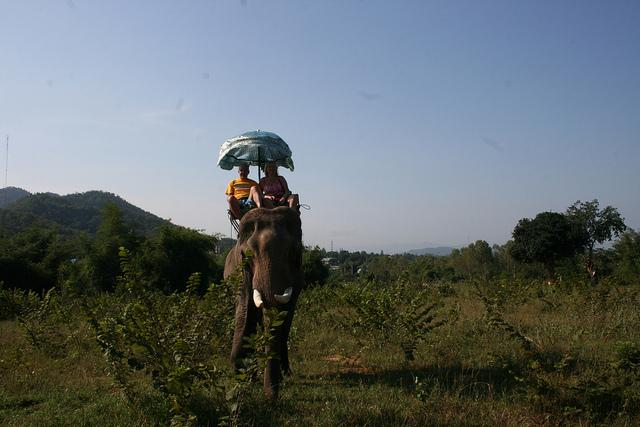What is the umbrella used to block?

Choices:
A) snow
B) hail
C) rain
D) sun sun 